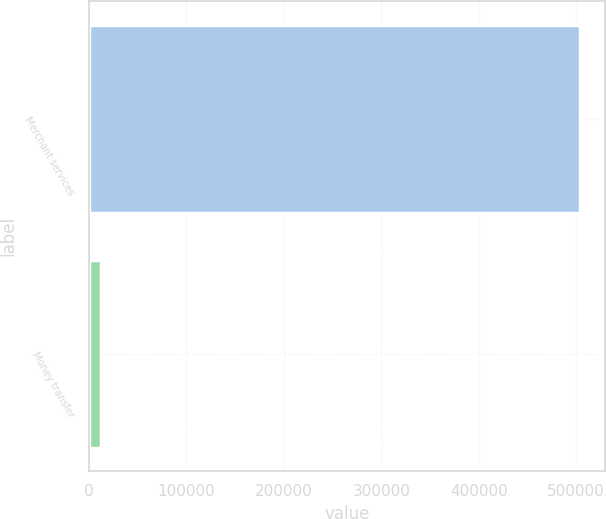<chart> <loc_0><loc_0><loc_500><loc_500><bar_chart><fcel>Merchant services<fcel>Money transfer<nl><fcel>503827<fcel>12257<nl></chart> 